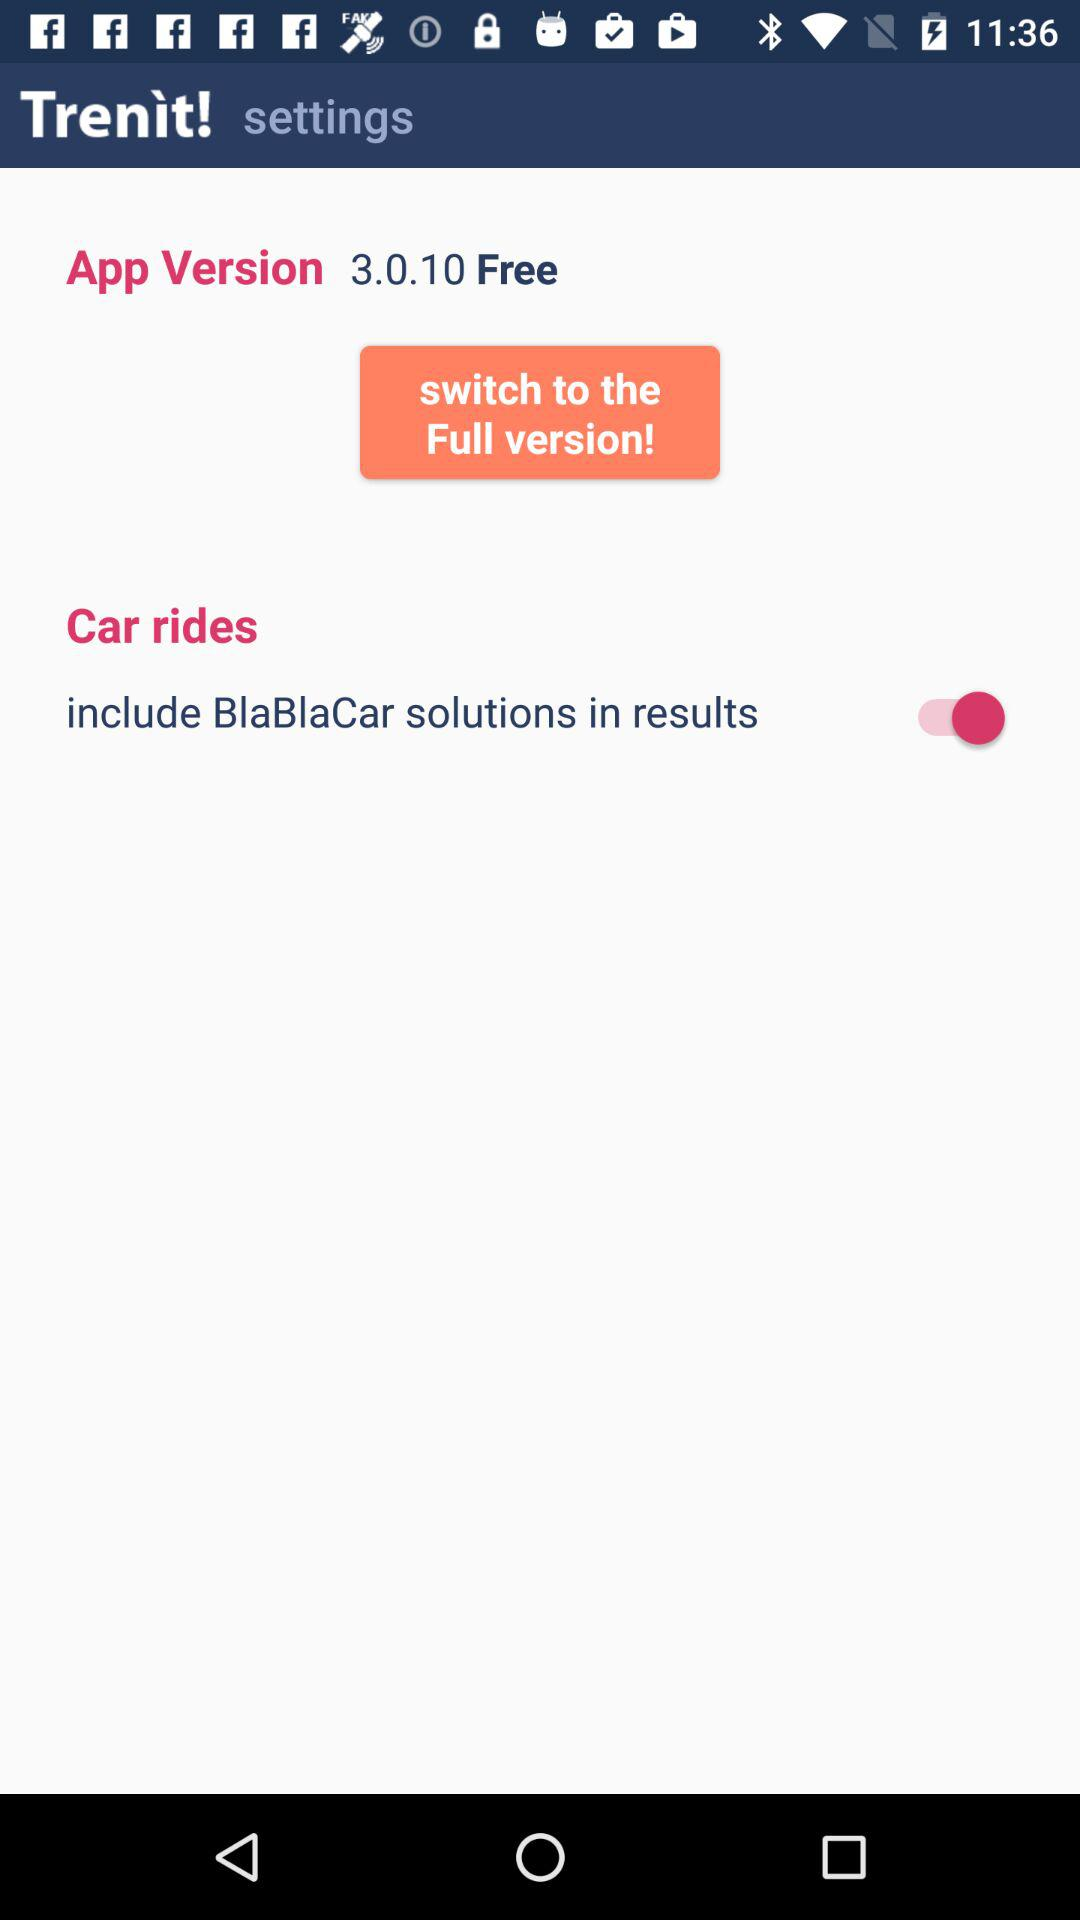Which application version is used? The used application version is 3.0.10. 